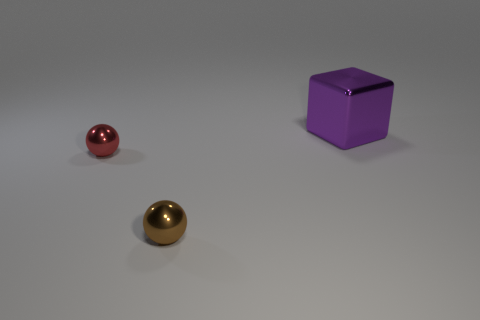Is there anything else that has the same material as the cube?
Provide a succinct answer. Yes. There is another small object that is the same shape as the red object; what is its material?
Offer a terse response. Metal. Is the number of big cubes left of the large purple metal thing less than the number of tiny brown spheres?
Your response must be concise. Yes. There is a tiny metal thing behind the tiny brown ball; is it the same shape as the purple thing?
Your answer should be compact. No. Is there any other thing that is the same color as the big object?
Keep it short and to the point. No. There is a brown object that is the same material as the big block; what size is it?
Your answer should be compact. Small. There is a ball that is in front of the metallic thing on the left side of the small sphere that is in front of the small red ball; what is it made of?
Offer a very short reply. Metal. Are there fewer red metal spheres than small things?
Your response must be concise. Yes. Do the tiny red object and the brown object have the same material?
Keep it short and to the point. Yes. There is a small shiny sphere that is on the right side of the small red shiny thing; is its color the same as the cube?
Ensure brevity in your answer.  No. 